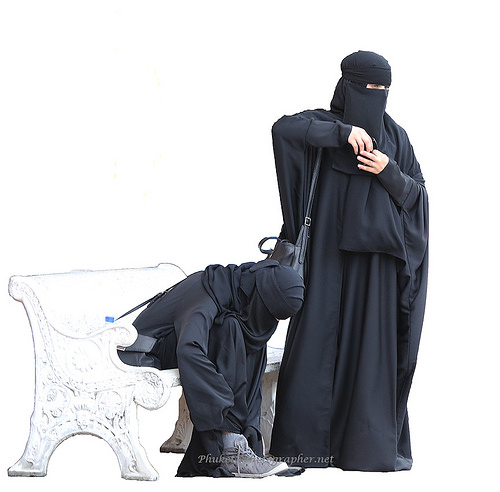<image>
Can you confirm if the woman is to the left of the woman? Yes. From this viewpoint, the woman is positioned to the left side relative to the woman. Is there a man next to the chair? No. The man is not positioned next to the chair. They are located in different areas of the scene. 